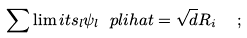Convert formula to latex. <formula><loc_0><loc_0><loc_500><loc_500>\sum \lim i t s _ { l } \psi _ { l } \ p l i h a t = \sqrt { d } R _ { i } \ \ ;</formula> 